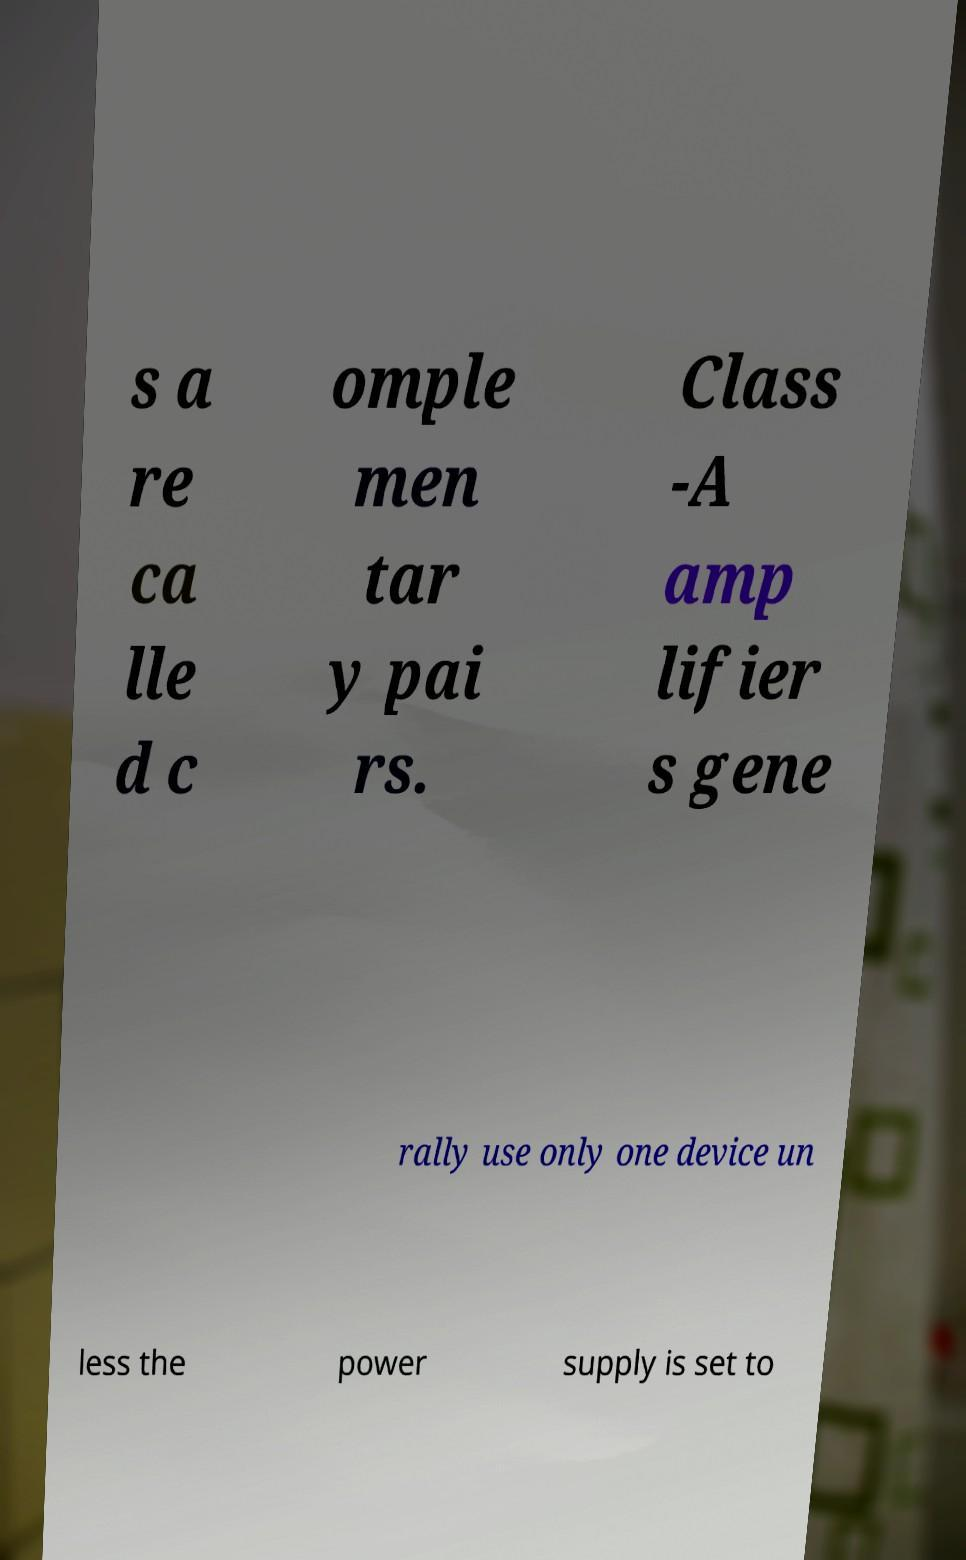There's text embedded in this image that I need extracted. Can you transcribe it verbatim? s a re ca lle d c omple men tar y pai rs. Class -A amp lifier s gene rally use only one device un less the power supply is set to 